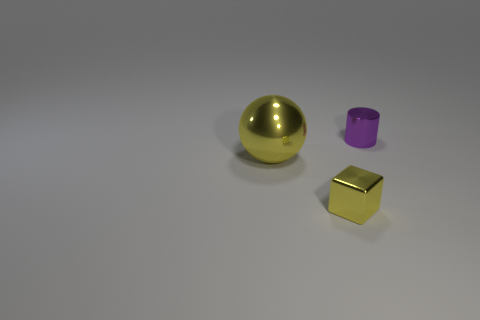Add 2 purple metallic cylinders. How many objects exist? 5 Subtract all cylinders. How many objects are left? 2 Subtract 1 balls. How many balls are left? 0 Subtract all blue blocks. Subtract all purple spheres. How many blocks are left? 1 Subtract all red blocks. How many gray cylinders are left? 0 Subtract all small rubber balls. Subtract all cylinders. How many objects are left? 2 Add 3 tiny cylinders. How many tiny cylinders are left? 4 Add 1 blocks. How many blocks exist? 2 Subtract 0 blue balls. How many objects are left? 3 